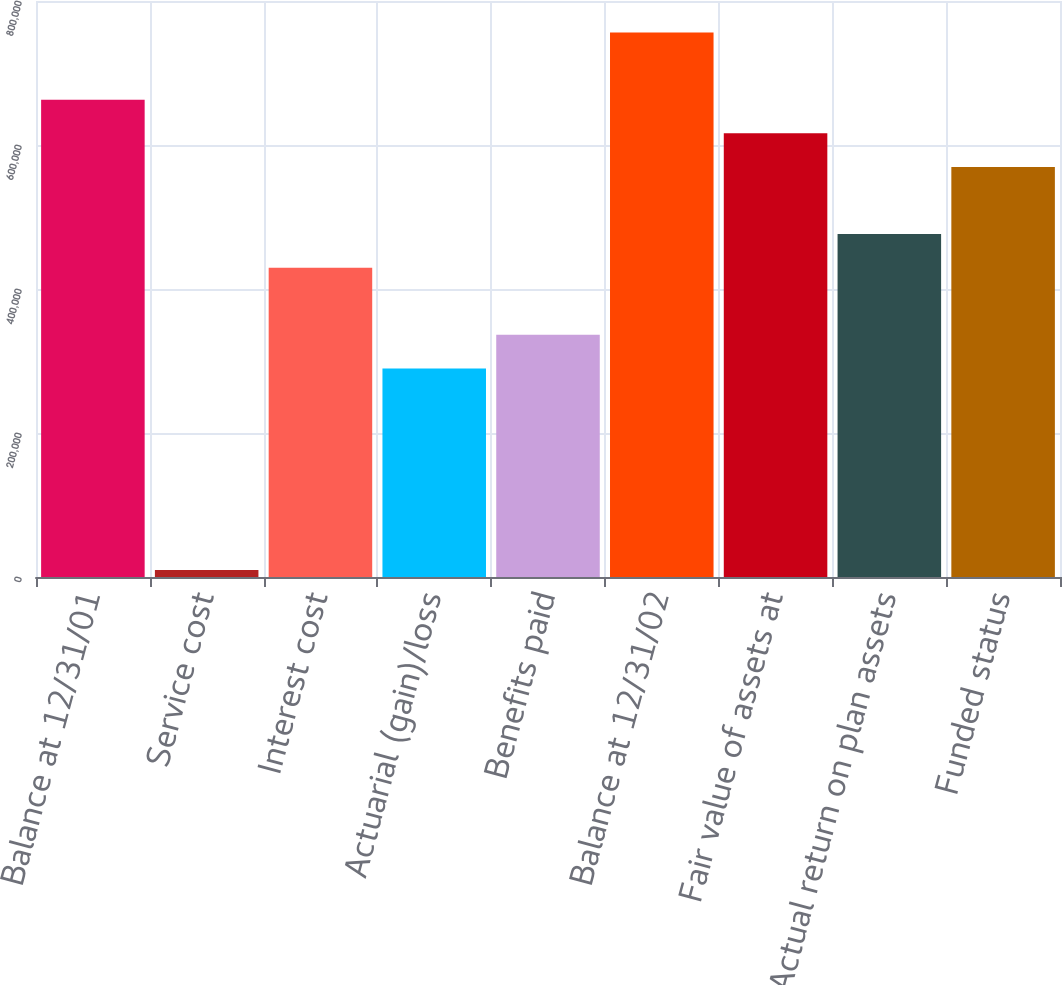Convert chart to OTSL. <chart><loc_0><loc_0><loc_500><loc_500><bar_chart><fcel>Balance at 12/31/01<fcel>Service cost<fcel>Interest cost<fcel>Actuarial (gain)/loss<fcel>Benefits paid<fcel>Balance at 12/31/02<fcel>Fair value of assets at<fcel>Actual return on plan assets<fcel>Funded status<nl><fcel>662872<fcel>9787<fcel>429627<fcel>289680<fcel>336329<fcel>756169<fcel>616223<fcel>476276<fcel>569574<nl></chart> 